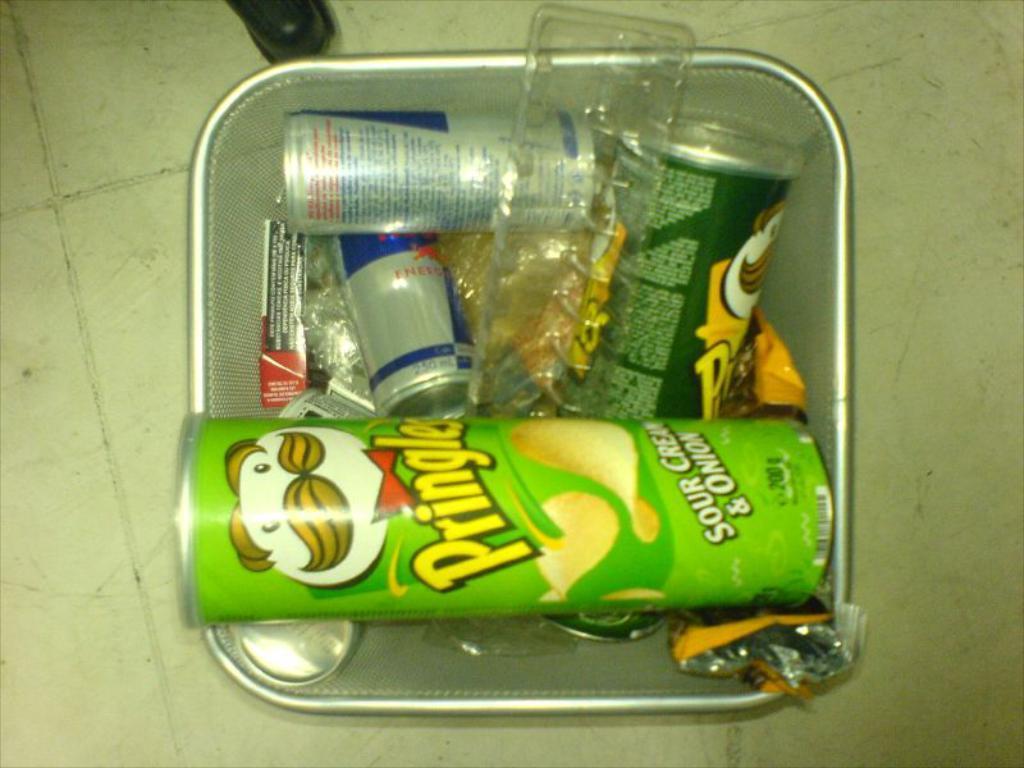Can you describe this image briefly? In this image I can see a box which is filled with some bottles and it is placed on the floor. 